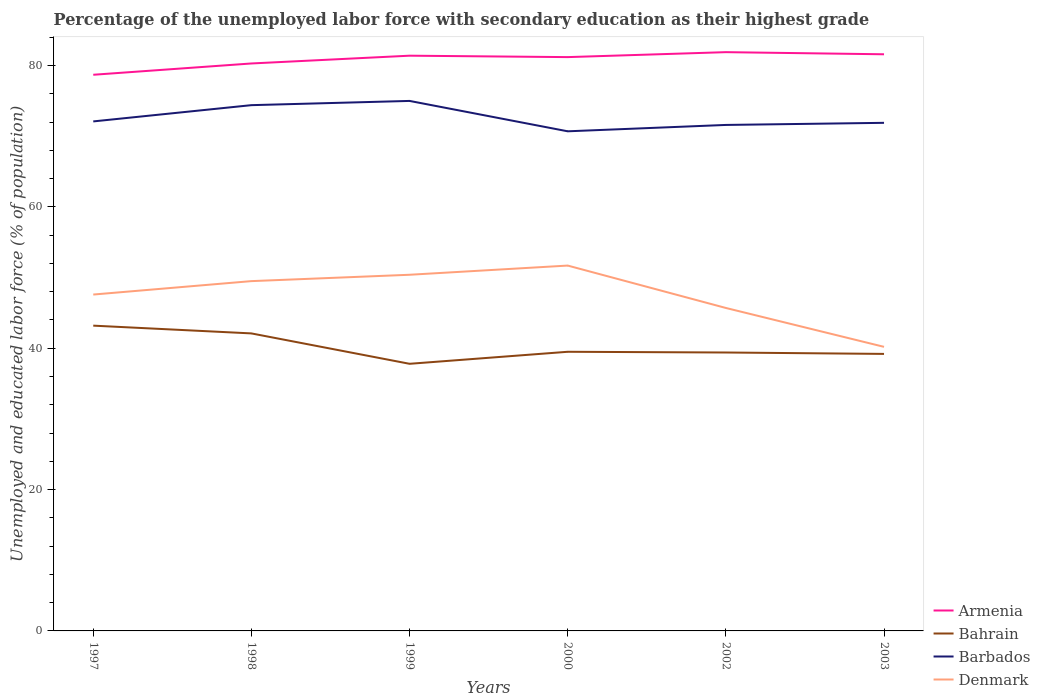How many different coloured lines are there?
Offer a very short reply. 4. Does the line corresponding to Denmark intersect with the line corresponding to Barbados?
Ensure brevity in your answer.  No. Is the number of lines equal to the number of legend labels?
Make the answer very short. Yes. Across all years, what is the maximum percentage of the unemployed labor force with secondary education in Bahrain?
Provide a short and direct response. 37.8. What is the total percentage of the unemployed labor force with secondary education in Armenia in the graph?
Your response must be concise. -0.5. What is the difference between the highest and the second highest percentage of the unemployed labor force with secondary education in Denmark?
Your answer should be compact. 11.5. How many years are there in the graph?
Provide a succinct answer. 6. What is the difference between two consecutive major ticks on the Y-axis?
Ensure brevity in your answer.  20. Where does the legend appear in the graph?
Your answer should be very brief. Bottom right. How many legend labels are there?
Keep it short and to the point. 4. What is the title of the graph?
Provide a short and direct response. Percentage of the unemployed labor force with secondary education as their highest grade. Does "Timor-Leste" appear as one of the legend labels in the graph?
Provide a short and direct response. No. What is the label or title of the X-axis?
Your response must be concise. Years. What is the label or title of the Y-axis?
Offer a terse response. Unemployed and educated labor force (% of population). What is the Unemployed and educated labor force (% of population) of Armenia in 1997?
Make the answer very short. 78.7. What is the Unemployed and educated labor force (% of population) of Bahrain in 1997?
Your answer should be very brief. 43.2. What is the Unemployed and educated labor force (% of population) in Barbados in 1997?
Keep it short and to the point. 72.1. What is the Unemployed and educated labor force (% of population) in Denmark in 1997?
Your response must be concise. 47.6. What is the Unemployed and educated labor force (% of population) in Armenia in 1998?
Keep it short and to the point. 80.3. What is the Unemployed and educated labor force (% of population) of Bahrain in 1998?
Give a very brief answer. 42.1. What is the Unemployed and educated labor force (% of population) of Barbados in 1998?
Your answer should be compact. 74.4. What is the Unemployed and educated labor force (% of population) in Denmark in 1998?
Make the answer very short. 49.5. What is the Unemployed and educated labor force (% of population) in Armenia in 1999?
Give a very brief answer. 81.4. What is the Unemployed and educated labor force (% of population) of Bahrain in 1999?
Ensure brevity in your answer.  37.8. What is the Unemployed and educated labor force (% of population) of Barbados in 1999?
Your answer should be very brief. 75. What is the Unemployed and educated labor force (% of population) in Denmark in 1999?
Your answer should be very brief. 50.4. What is the Unemployed and educated labor force (% of population) of Armenia in 2000?
Ensure brevity in your answer.  81.2. What is the Unemployed and educated labor force (% of population) in Bahrain in 2000?
Provide a succinct answer. 39.5. What is the Unemployed and educated labor force (% of population) in Barbados in 2000?
Offer a very short reply. 70.7. What is the Unemployed and educated labor force (% of population) in Denmark in 2000?
Give a very brief answer. 51.7. What is the Unemployed and educated labor force (% of population) in Armenia in 2002?
Your response must be concise. 81.9. What is the Unemployed and educated labor force (% of population) in Bahrain in 2002?
Your answer should be very brief. 39.4. What is the Unemployed and educated labor force (% of population) in Barbados in 2002?
Your answer should be very brief. 71.6. What is the Unemployed and educated labor force (% of population) of Denmark in 2002?
Offer a terse response. 45.7. What is the Unemployed and educated labor force (% of population) in Armenia in 2003?
Your answer should be very brief. 81.6. What is the Unemployed and educated labor force (% of population) in Bahrain in 2003?
Ensure brevity in your answer.  39.2. What is the Unemployed and educated labor force (% of population) in Barbados in 2003?
Offer a very short reply. 71.9. What is the Unemployed and educated labor force (% of population) of Denmark in 2003?
Your answer should be compact. 40.2. Across all years, what is the maximum Unemployed and educated labor force (% of population) of Armenia?
Give a very brief answer. 81.9. Across all years, what is the maximum Unemployed and educated labor force (% of population) of Bahrain?
Your response must be concise. 43.2. Across all years, what is the maximum Unemployed and educated labor force (% of population) in Denmark?
Your answer should be very brief. 51.7. Across all years, what is the minimum Unemployed and educated labor force (% of population) of Armenia?
Provide a succinct answer. 78.7. Across all years, what is the minimum Unemployed and educated labor force (% of population) in Bahrain?
Make the answer very short. 37.8. Across all years, what is the minimum Unemployed and educated labor force (% of population) in Barbados?
Your response must be concise. 70.7. Across all years, what is the minimum Unemployed and educated labor force (% of population) of Denmark?
Provide a short and direct response. 40.2. What is the total Unemployed and educated labor force (% of population) in Armenia in the graph?
Offer a terse response. 485.1. What is the total Unemployed and educated labor force (% of population) in Bahrain in the graph?
Give a very brief answer. 241.2. What is the total Unemployed and educated labor force (% of population) of Barbados in the graph?
Your answer should be very brief. 435.7. What is the total Unemployed and educated labor force (% of population) in Denmark in the graph?
Your answer should be very brief. 285.1. What is the difference between the Unemployed and educated labor force (% of population) of Armenia in 1997 and that in 1998?
Keep it short and to the point. -1.6. What is the difference between the Unemployed and educated labor force (% of population) of Bahrain in 1997 and that in 1998?
Your response must be concise. 1.1. What is the difference between the Unemployed and educated labor force (% of population) of Barbados in 1997 and that in 1998?
Your answer should be very brief. -2.3. What is the difference between the Unemployed and educated labor force (% of population) in Armenia in 1997 and that in 1999?
Your answer should be very brief. -2.7. What is the difference between the Unemployed and educated labor force (% of population) of Bahrain in 1997 and that in 1999?
Your answer should be very brief. 5.4. What is the difference between the Unemployed and educated labor force (% of population) of Barbados in 1997 and that in 1999?
Keep it short and to the point. -2.9. What is the difference between the Unemployed and educated labor force (% of population) of Denmark in 1997 and that in 1999?
Your response must be concise. -2.8. What is the difference between the Unemployed and educated labor force (% of population) of Armenia in 1997 and that in 2000?
Provide a succinct answer. -2.5. What is the difference between the Unemployed and educated labor force (% of population) of Barbados in 1997 and that in 2000?
Your answer should be compact. 1.4. What is the difference between the Unemployed and educated labor force (% of population) in Armenia in 1997 and that in 2002?
Ensure brevity in your answer.  -3.2. What is the difference between the Unemployed and educated labor force (% of population) of Bahrain in 1997 and that in 2002?
Your answer should be very brief. 3.8. What is the difference between the Unemployed and educated labor force (% of population) in Barbados in 1997 and that in 2002?
Your answer should be very brief. 0.5. What is the difference between the Unemployed and educated labor force (% of population) of Denmark in 1997 and that in 2002?
Keep it short and to the point. 1.9. What is the difference between the Unemployed and educated labor force (% of population) of Armenia in 1997 and that in 2003?
Provide a succinct answer. -2.9. What is the difference between the Unemployed and educated labor force (% of population) in Barbados in 1997 and that in 2003?
Offer a terse response. 0.2. What is the difference between the Unemployed and educated labor force (% of population) in Denmark in 1997 and that in 2003?
Offer a terse response. 7.4. What is the difference between the Unemployed and educated labor force (% of population) in Armenia in 1998 and that in 1999?
Offer a terse response. -1.1. What is the difference between the Unemployed and educated labor force (% of population) in Bahrain in 1998 and that in 1999?
Your answer should be compact. 4.3. What is the difference between the Unemployed and educated labor force (% of population) of Barbados in 1998 and that in 2000?
Keep it short and to the point. 3.7. What is the difference between the Unemployed and educated labor force (% of population) in Denmark in 1998 and that in 2000?
Offer a very short reply. -2.2. What is the difference between the Unemployed and educated labor force (% of population) of Denmark in 1998 and that in 2002?
Offer a very short reply. 3.8. What is the difference between the Unemployed and educated labor force (% of population) in Armenia in 1998 and that in 2003?
Your answer should be compact. -1.3. What is the difference between the Unemployed and educated labor force (% of population) in Barbados in 1998 and that in 2003?
Make the answer very short. 2.5. What is the difference between the Unemployed and educated labor force (% of population) of Bahrain in 1999 and that in 2000?
Your answer should be very brief. -1.7. What is the difference between the Unemployed and educated labor force (% of population) of Barbados in 1999 and that in 2000?
Give a very brief answer. 4.3. What is the difference between the Unemployed and educated labor force (% of population) in Armenia in 1999 and that in 2002?
Provide a short and direct response. -0.5. What is the difference between the Unemployed and educated labor force (% of population) of Barbados in 1999 and that in 2002?
Your response must be concise. 3.4. What is the difference between the Unemployed and educated labor force (% of population) of Armenia in 1999 and that in 2003?
Offer a very short reply. -0.2. What is the difference between the Unemployed and educated labor force (% of population) of Bahrain in 1999 and that in 2003?
Ensure brevity in your answer.  -1.4. What is the difference between the Unemployed and educated labor force (% of population) of Barbados in 1999 and that in 2003?
Give a very brief answer. 3.1. What is the difference between the Unemployed and educated labor force (% of population) of Bahrain in 2000 and that in 2002?
Your answer should be very brief. 0.1. What is the difference between the Unemployed and educated labor force (% of population) of Denmark in 2000 and that in 2003?
Your response must be concise. 11.5. What is the difference between the Unemployed and educated labor force (% of population) of Armenia in 2002 and that in 2003?
Keep it short and to the point. 0.3. What is the difference between the Unemployed and educated labor force (% of population) of Armenia in 1997 and the Unemployed and educated labor force (% of population) of Bahrain in 1998?
Your answer should be very brief. 36.6. What is the difference between the Unemployed and educated labor force (% of population) of Armenia in 1997 and the Unemployed and educated labor force (% of population) of Denmark in 1998?
Your response must be concise. 29.2. What is the difference between the Unemployed and educated labor force (% of population) in Bahrain in 1997 and the Unemployed and educated labor force (% of population) in Barbados in 1998?
Give a very brief answer. -31.2. What is the difference between the Unemployed and educated labor force (% of population) in Barbados in 1997 and the Unemployed and educated labor force (% of population) in Denmark in 1998?
Offer a very short reply. 22.6. What is the difference between the Unemployed and educated labor force (% of population) of Armenia in 1997 and the Unemployed and educated labor force (% of population) of Bahrain in 1999?
Offer a terse response. 40.9. What is the difference between the Unemployed and educated labor force (% of population) in Armenia in 1997 and the Unemployed and educated labor force (% of population) in Barbados in 1999?
Your answer should be very brief. 3.7. What is the difference between the Unemployed and educated labor force (% of population) of Armenia in 1997 and the Unemployed and educated labor force (% of population) of Denmark in 1999?
Give a very brief answer. 28.3. What is the difference between the Unemployed and educated labor force (% of population) in Bahrain in 1997 and the Unemployed and educated labor force (% of population) in Barbados in 1999?
Give a very brief answer. -31.8. What is the difference between the Unemployed and educated labor force (% of population) in Bahrain in 1997 and the Unemployed and educated labor force (% of population) in Denmark in 1999?
Your response must be concise. -7.2. What is the difference between the Unemployed and educated labor force (% of population) in Barbados in 1997 and the Unemployed and educated labor force (% of population) in Denmark in 1999?
Your answer should be very brief. 21.7. What is the difference between the Unemployed and educated labor force (% of population) in Armenia in 1997 and the Unemployed and educated labor force (% of population) in Bahrain in 2000?
Provide a short and direct response. 39.2. What is the difference between the Unemployed and educated labor force (% of population) in Bahrain in 1997 and the Unemployed and educated labor force (% of population) in Barbados in 2000?
Your answer should be compact. -27.5. What is the difference between the Unemployed and educated labor force (% of population) in Bahrain in 1997 and the Unemployed and educated labor force (% of population) in Denmark in 2000?
Offer a very short reply. -8.5. What is the difference between the Unemployed and educated labor force (% of population) of Barbados in 1997 and the Unemployed and educated labor force (% of population) of Denmark in 2000?
Make the answer very short. 20.4. What is the difference between the Unemployed and educated labor force (% of population) of Armenia in 1997 and the Unemployed and educated labor force (% of population) of Bahrain in 2002?
Offer a terse response. 39.3. What is the difference between the Unemployed and educated labor force (% of population) in Armenia in 1997 and the Unemployed and educated labor force (% of population) in Denmark in 2002?
Make the answer very short. 33. What is the difference between the Unemployed and educated labor force (% of population) in Bahrain in 1997 and the Unemployed and educated labor force (% of population) in Barbados in 2002?
Ensure brevity in your answer.  -28.4. What is the difference between the Unemployed and educated labor force (% of population) in Barbados in 1997 and the Unemployed and educated labor force (% of population) in Denmark in 2002?
Provide a succinct answer. 26.4. What is the difference between the Unemployed and educated labor force (% of population) of Armenia in 1997 and the Unemployed and educated labor force (% of population) of Bahrain in 2003?
Your answer should be compact. 39.5. What is the difference between the Unemployed and educated labor force (% of population) of Armenia in 1997 and the Unemployed and educated labor force (% of population) of Barbados in 2003?
Make the answer very short. 6.8. What is the difference between the Unemployed and educated labor force (% of population) of Armenia in 1997 and the Unemployed and educated labor force (% of population) of Denmark in 2003?
Ensure brevity in your answer.  38.5. What is the difference between the Unemployed and educated labor force (% of population) of Bahrain in 1997 and the Unemployed and educated labor force (% of population) of Barbados in 2003?
Provide a succinct answer. -28.7. What is the difference between the Unemployed and educated labor force (% of population) of Barbados in 1997 and the Unemployed and educated labor force (% of population) of Denmark in 2003?
Ensure brevity in your answer.  31.9. What is the difference between the Unemployed and educated labor force (% of population) in Armenia in 1998 and the Unemployed and educated labor force (% of population) in Bahrain in 1999?
Make the answer very short. 42.5. What is the difference between the Unemployed and educated labor force (% of population) in Armenia in 1998 and the Unemployed and educated labor force (% of population) in Barbados in 1999?
Give a very brief answer. 5.3. What is the difference between the Unemployed and educated labor force (% of population) of Armenia in 1998 and the Unemployed and educated labor force (% of population) of Denmark in 1999?
Offer a terse response. 29.9. What is the difference between the Unemployed and educated labor force (% of population) in Bahrain in 1998 and the Unemployed and educated labor force (% of population) in Barbados in 1999?
Keep it short and to the point. -32.9. What is the difference between the Unemployed and educated labor force (% of population) of Bahrain in 1998 and the Unemployed and educated labor force (% of population) of Denmark in 1999?
Offer a very short reply. -8.3. What is the difference between the Unemployed and educated labor force (% of population) in Armenia in 1998 and the Unemployed and educated labor force (% of population) in Bahrain in 2000?
Your answer should be compact. 40.8. What is the difference between the Unemployed and educated labor force (% of population) of Armenia in 1998 and the Unemployed and educated labor force (% of population) of Barbados in 2000?
Provide a succinct answer. 9.6. What is the difference between the Unemployed and educated labor force (% of population) in Armenia in 1998 and the Unemployed and educated labor force (% of population) in Denmark in 2000?
Your answer should be compact. 28.6. What is the difference between the Unemployed and educated labor force (% of population) of Bahrain in 1998 and the Unemployed and educated labor force (% of population) of Barbados in 2000?
Provide a succinct answer. -28.6. What is the difference between the Unemployed and educated labor force (% of population) of Barbados in 1998 and the Unemployed and educated labor force (% of population) of Denmark in 2000?
Give a very brief answer. 22.7. What is the difference between the Unemployed and educated labor force (% of population) of Armenia in 1998 and the Unemployed and educated labor force (% of population) of Bahrain in 2002?
Provide a short and direct response. 40.9. What is the difference between the Unemployed and educated labor force (% of population) of Armenia in 1998 and the Unemployed and educated labor force (% of population) of Denmark in 2002?
Keep it short and to the point. 34.6. What is the difference between the Unemployed and educated labor force (% of population) of Bahrain in 1998 and the Unemployed and educated labor force (% of population) of Barbados in 2002?
Give a very brief answer. -29.5. What is the difference between the Unemployed and educated labor force (% of population) of Barbados in 1998 and the Unemployed and educated labor force (% of population) of Denmark in 2002?
Make the answer very short. 28.7. What is the difference between the Unemployed and educated labor force (% of population) in Armenia in 1998 and the Unemployed and educated labor force (% of population) in Bahrain in 2003?
Offer a very short reply. 41.1. What is the difference between the Unemployed and educated labor force (% of population) of Armenia in 1998 and the Unemployed and educated labor force (% of population) of Barbados in 2003?
Provide a short and direct response. 8.4. What is the difference between the Unemployed and educated labor force (% of population) in Armenia in 1998 and the Unemployed and educated labor force (% of population) in Denmark in 2003?
Make the answer very short. 40.1. What is the difference between the Unemployed and educated labor force (% of population) in Bahrain in 1998 and the Unemployed and educated labor force (% of population) in Barbados in 2003?
Give a very brief answer. -29.8. What is the difference between the Unemployed and educated labor force (% of population) in Bahrain in 1998 and the Unemployed and educated labor force (% of population) in Denmark in 2003?
Your answer should be compact. 1.9. What is the difference between the Unemployed and educated labor force (% of population) in Barbados in 1998 and the Unemployed and educated labor force (% of population) in Denmark in 2003?
Your response must be concise. 34.2. What is the difference between the Unemployed and educated labor force (% of population) in Armenia in 1999 and the Unemployed and educated labor force (% of population) in Bahrain in 2000?
Your answer should be compact. 41.9. What is the difference between the Unemployed and educated labor force (% of population) in Armenia in 1999 and the Unemployed and educated labor force (% of population) in Denmark in 2000?
Your answer should be very brief. 29.7. What is the difference between the Unemployed and educated labor force (% of population) in Bahrain in 1999 and the Unemployed and educated labor force (% of population) in Barbados in 2000?
Your answer should be very brief. -32.9. What is the difference between the Unemployed and educated labor force (% of population) in Barbados in 1999 and the Unemployed and educated labor force (% of population) in Denmark in 2000?
Provide a succinct answer. 23.3. What is the difference between the Unemployed and educated labor force (% of population) of Armenia in 1999 and the Unemployed and educated labor force (% of population) of Denmark in 2002?
Make the answer very short. 35.7. What is the difference between the Unemployed and educated labor force (% of population) in Bahrain in 1999 and the Unemployed and educated labor force (% of population) in Barbados in 2002?
Offer a terse response. -33.8. What is the difference between the Unemployed and educated labor force (% of population) in Barbados in 1999 and the Unemployed and educated labor force (% of population) in Denmark in 2002?
Your answer should be compact. 29.3. What is the difference between the Unemployed and educated labor force (% of population) of Armenia in 1999 and the Unemployed and educated labor force (% of population) of Bahrain in 2003?
Your answer should be compact. 42.2. What is the difference between the Unemployed and educated labor force (% of population) of Armenia in 1999 and the Unemployed and educated labor force (% of population) of Barbados in 2003?
Your response must be concise. 9.5. What is the difference between the Unemployed and educated labor force (% of population) in Armenia in 1999 and the Unemployed and educated labor force (% of population) in Denmark in 2003?
Keep it short and to the point. 41.2. What is the difference between the Unemployed and educated labor force (% of population) of Bahrain in 1999 and the Unemployed and educated labor force (% of population) of Barbados in 2003?
Provide a short and direct response. -34.1. What is the difference between the Unemployed and educated labor force (% of population) of Barbados in 1999 and the Unemployed and educated labor force (% of population) of Denmark in 2003?
Your answer should be compact. 34.8. What is the difference between the Unemployed and educated labor force (% of population) in Armenia in 2000 and the Unemployed and educated labor force (% of population) in Bahrain in 2002?
Ensure brevity in your answer.  41.8. What is the difference between the Unemployed and educated labor force (% of population) in Armenia in 2000 and the Unemployed and educated labor force (% of population) in Barbados in 2002?
Give a very brief answer. 9.6. What is the difference between the Unemployed and educated labor force (% of population) of Armenia in 2000 and the Unemployed and educated labor force (% of population) of Denmark in 2002?
Make the answer very short. 35.5. What is the difference between the Unemployed and educated labor force (% of population) of Bahrain in 2000 and the Unemployed and educated labor force (% of population) of Barbados in 2002?
Provide a succinct answer. -32.1. What is the difference between the Unemployed and educated labor force (% of population) of Bahrain in 2000 and the Unemployed and educated labor force (% of population) of Denmark in 2002?
Your answer should be very brief. -6.2. What is the difference between the Unemployed and educated labor force (% of population) in Barbados in 2000 and the Unemployed and educated labor force (% of population) in Denmark in 2002?
Ensure brevity in your answer.  25. What is the difference between the Unemployed and educated labor force (% of population) in Armenia in 2000 and the Unemployed and educated labor force (% of population) in Bahrain in 2003?
Keep it short and to the point. 42. What is the difference between the Unemployed and educated labor force (% of population) of Armenia in 2000 and the Unemployed and educated labor force (% of population) of Denmark in 2003?
Provide a succinct answer. 41. What is the difference between the Unemployed and educated labor force (% of population) of Bahrain in 2000 and the Unemployed and educated labor force (% of population) of Barbados in 2003?
Your response must be concise. -32.4. What is the difference between the Unemployed and educated labor force (% of population) of Barbados in 2000 and the Unemployed and educated labor force (% of population) of Denmark in 2003?
Provide a succinct answer. 30.5. What is the difference between the Unemployed and educated labor force (% of population) of Armenia in 2002 and the Unemployed and educated labor force (% of population) of Bahrain in 2003?
Make the answer very short. 42.7. What is the difference between the Unemployed and educated labor force (% of population) in Armenia in 2002 and the Unemployed and educated labor force (% of population) in Denmark in 2003?
Offer a terse response. 41.7. What is the difference between the Unemployed and educated labor force (% of population) in Bahrain in 2002 and the Unemployed and educated labor force (% of population) in Barbados in 2003?
Give a very brief answer. -32.5. What is the difference between the Unemployed and educated labor force (% of population) in Bahrain in 2002 and the Unemployed and educated labor force (% of population) in Denmark in 2003?
Offer a very short reply. -0.8. What is the difference between the Unemployed and educated labor force (% of population) of Barbados in 2002 and the Unemployed and educated labor force (% of population) of Denmark in 2003?
Offer a very short reply. 31.4. What is the average Unemployed and educated labor force (% of population) of Armenia per year?
Make the answer very short. 80.85. What is the average Unemployed and educated labor force (% of population) of Bahrain per year?
Offer a very short reply. 40.2. What is the average Unemployed and educated labor force (% of population) in Barbados per year?
Keep it short and to the point. 72.62. What is the average Unemployed and educated labor force (% of population) in Denmark per year?
Give a very brief answer. 47.52. In the year 1997, what is the difference between the Unemployed and educated labor force (% of population) of Armenia and Unemployed and educated labor force (% of population) of Bahrain?
Keep it short and to the point. 35.5. In the year 1997, what is the difference between the Unemployed and educated labor force (% of population) in Armenia and Unemployed and educated labor force (% of population) in Denmark?
Offer a terse response. 31.1. In the year 1997, what is the difference between the Unemployed and educated labor force (% of population) in Bahrain and Unemployed and educated labor force (% of population) in Barbados?
Offer a very short reply. -28.9. In the year 1997, what is the difference between the Unemployed and educated labor force (% of population) in Bahrain and Unemployed and educated labor force (% of population) in Denmark?
Ensure brevity in your answer.  -4.4. In the year 1998, what is the difference between the Unemployed and educated labor force (% of population) of Armenia and Unemployed and educated labor force (% of population) of Bahrain?
Offer a very short reply. 38.2. In the year 1998, what is the difference between the Unemployed and educated labor force (% of population) in Armenia and Unemployed and educated labor force (% of population) in Barbados?
Ensure brevity in your answer.  5.9. In the year 1998, what is the difference between the Unemployed and educated labor force (% of population) of Armenia and Unemployed and educated labor force (% of population) of Denmark?
Provide a short and direct response. 30.8. In the year 1998, what is the difference between the Unemployed and educated labor force (% of population) of Bahrain and Unemployed and educated labor force (% of population) of Barbados?
Your answer should be compact. -32.3. In the year 1998, what is the difference between the Unemployed and educated labor force (% of population) of Barbados and Unemployed and educated labor force (% of population) of Denmark?
Give a very brief answer. 24.9. In the year 1999, what is the difference between the Unemployed and educated labor force (% of population) of Armenia and Unemployed and educated labor force (% of population) of Bahrain?
Ensure brevity in your answer.  43.6. In the year 1999, what is the difference between the Unemployed and educated labor force (% of population) of Armenia and Unemployed and educated labor force (% of population) of Barbados?
Provide a succinct answer. 6.4. In the year 1999, what is the difference between the Unemployed and educated labor force (% of population) of Armenia and Unemployed and educated labor force (% of population) of Denmark?
Keep it short and to the point. 31. In the year 1999, what is the difference between the Unemployed and educated labor force (% of population) in Bahrain and Unemployed and educated labor force (% of population) in Barbados?
Offer a very short reply. -37.2. In the year 1999, what is the difference between the Unemployed and educated labor force (% of population) in Bahrain and Unemployed and educated labor force (% of population) in Denmark?
Your response must be concise. -12.6. In the year 1999, what is the difference between the Unemployed and educated labor force (% of population) of Barbados and Unemployed and educated labor force (% of population) of Denmark?
Offer a very short reply. 24.6. In the year 2000, what is the difference between the Unemployed and educated labor force (% of population) in Armenia and Unemployed and educated labor force (% of population) in Bahrain?
Give a very brief answer. 41.7. In the year 2000, what is the difference between the Unemployed and educated labor force (% of population) of Armenia and Unemployed and educated labor force (% of population) of Barbados?
Give a very brief answer. 10.5. In the year 2000, what is the difference between the Unemployed and educated labor force (% of population) of Armenia and Unemployed and educated labor force (% of population) of Denmark?
Ensure brevity in your answer.  29.5. In the year 2000, what is the difference between the Unemployed and educated labor force (% of population) in Bahrain and Unemployed and educated labor force (% of population) in Barbados?
Offer a terse response. -31.2. In the year 2000, what is the difference between the Unemployed and educated labor force (% of population) in Bahrain and Unemployed and educated labor force (% of population) in Denmark?
Your answer should be compact. -12.2. In the year 2002, what is the difference between the Unemployed and educated labor force (% of population) in Armenia and Unemployed and educated labor force (% of population) in Bahrain?
Provide a short and direct response. 42.5. In the year 2002, what is the difference between the Unemployed and educated labor force (% of population) in Armenia and Unemployed and educated labor force (% of population) in Barbados?
Offer a terse response. 10.3. In the year 2002, what is the difference between the Unemployed and educated labor force (% of population) of Armenia and Unemployed and educated labor force (% of population) of Denmark?
Your answer should be compact. 36.2. In the year 2002, what is the difference between the Unemployed and educated labor force (% of population) in Bahrain and Unemployed and educated labor force (% of population) in Barbados?
Offer a very short reply. -32.2. In the year 2002, what is the difference between the Unemployed and educated labor force (% of population) in Bahrain and Unemployed and educated labor force (% of population) in Denmark?
Your answer should be compact. -6.3. In the year 2002, what is the difference between the Unemployed and educated labor force (% of population) of Barbados and Unemployed and educated labor force (% of population) of Denmark?
Ensure brevity in your answer.  25.9. In the year 2003, what is the difference between the Unemployed and educated labor force (% of population) of Armenia and Unemployed and educated labor force (% of population) of Bahrain?
Your response must be concise. 42.4. In the year 2003, what is the difference between the Unemployed and educated labor force (% of population) of Armenia and Unemployed and educated labor force (% of population) of Denmark?
Offer a very short reply. 41.4. In the year 2003, what is the difference between the Unemployed and educated labor force (% of population) of Bahrain and Unemployed and educated labor force (% of population) of Barbados?
Offer a terse response. -32.7. In the year 2003, what is the difference between the Unemployed and educated labor force (% of population) of Barbados and Unemployed and educated labor force (% of population) of Denmark?
Make the answer very short. 31.7. What is the ratio of the Unemployed and educated labor force (% of population) of Armenia in 1997 to that in 1998?
Provide a short and direct response. 0.98. What is the ratio of the Unemployed and educated labor force (% of population) in Bahrain in 1997 to that in 1998?
Your answer should be compact. 1.03. What is the ratio of the Unemployed and educated labor force (% of population) in Barbados in 1997 to that in 1998?
Provide a succinct answer. 0.97. What is the ratio of the Unemployed and educated labor force (% of population) in Denmark in 1997 to that in 1998?
Make the answer very short. 0.96. What is the ratio of the Unemployed and educated labor force (% of population) in Armenia in 1997 to that in 1999?
Your answer should be compact. 0.97. What is the ratio of the Unemployed and educated labor force (% of population) in Bahrain in 1997 to that in 1999?
Your response must be concise. 1.14. What is the ratio of the Unemployed and educated labor force (% of population) of Barbados in 1997 to that in 1999?
Provide a short and direct response. 0.96. What is the ratio of the Unemployed and educated labor force (% of population) of Armenia in 1997 to that in 2000?
Offer a terse response. 0.97. What is the ratio of the Unemployed and educated labor force (% of population) in Bahrain in 1997 to that in 2000?
Keep it short and to the point. 1.09. What is the ratio of the Unemployed and educated labor force (% of population) of Barbados in 1997 to that in 2000?
Your answer should be very brief. 1.02. What is the ratio of the Unemployed and educated labor force (% of population) of Denmark in 1997 to that in 2000?
Ensure brevity in your answer.  0.92. What is the ratio of the Unemployed and educated labor force (% of population) in Armenia in 1997 to that in 2002?
Your response must be concise. 0.96. What is the ratio of the Unemployed and educated labor force (% of population) in Bahrain in 1997 to that in 2002?
Your response must be concise. 1.1. What is the ratio of the Unemployed and educated labor force (% of population) of Denmark in 1997 to that in 2002?
Provide a short and direct response. 1.04. What is the ratio of the Unemployed and educated labor force (% of population) in Armenia in 1997 to that in 2003?
Your answer should be very brief. 0.96. What is the ratio of the Unemployed and educated labor force (% of population) of Bahrain in 1997 to that in 2003?
Your answer should be very brief. 1.1. What is the ratio of the Unemployed and educated labor force (% of population) in Barbados in 1997 to that in 2003?
Offer a very short reply. 1. What is the ratio of the Unemployed and educated labor force (% of population) in Denmark in 1997 to that in 2003?
Your answer should be compact. 1.18. What is the ratio of the Unemployed and educated labor force (% of population) in Armenia in 1998 to that in 1999?
Your answer should be very brief. 0.99. What is the ratio of the Unemployed and educated labor force (% of population) of Bahrain in 1998 to that in 1999?
Your answer should be compact. 1.11. What is the ratio of the Unemployed and educated labor force (% of population) in Denmark in 1998 to that in 1999?
Your answer should be very brief. 0.98. What is the ratio of the Unemployed and educated labor force (% of population) of Armenia in 1998 to that in 2000?
Provide a succinct answer. 0.99. What is the ratio of the Unemployed and educated labor force (% of population) in Bahrain in 1998 to that in 2000?
Your response must be concise. 1.07. What is the ratio of the Unemployed and educated labor force (% of population) in Barbados in 1998 to that in 2000?
Give a very brief answer. 1.05. What is the ratio of the Unemployed and educated labor force (% of population) of Denmark in 1998 to that in 2000?
Your response must be concise. 0.96. What is the ratio of the Unemployed and educated labor force (% of population) of Armenia in 1998 to that in 2002?
Provide a succinct answer. 0.98. What is the ratio of the Unemployed and educated labor force (% of population) in Bahrain in 1998 to that in 2002?
Your answer should be compact. 1.07. What is the ratio of the Unemployed and educated labor force (% of population) of Barbados in 1998 to that in 2002?
Offer a very short reply. 1.04. What is the ratio of the Unemployed and educated labor force (% of population) in Denmark in 1998 to that in 2002?
Your answer should be very brief. 1.08. What is the ratio of the Unemployed and educated labor force (% of population) of Armenia in 1998 to that in 2003?
Ensure brevity in your answer.  0.98. What is the ratio of the Unemployed and educated labor force (% of population) in Bahrain in 1998 to that in 2003?
Keep it short and to the point. 1.07. What is the ratio of the Unemployed and educated labor force (% of population) of Barbados in 1998 to that in 2003?
Your answer should be compact. 1.03. What is the ratio of the Unemployed and educated labor force (% of population) in Denmark in 1998 to that in 2003?
Offer a terse response. 1.23. What is the ratio of the Unemployed and educated labor force (% of population) in Bahrain in 1999 to that in 2000?
Make the answer very short. 0.96. What is the ratio of the Unemployed and educated labor force (% of population) of Barbados in 1999 to that in 2000?
Your answer should be compact. 1.06. What is the ratio of the Unemployed and educated labor force (% of population) of Denmark in 1999 to that in 2000?
Ensure brevity in your answer.  0.97. What is the ratio of the Unemployed and educated labor force (% of population) of Armenia in 1999 to that in 2002?
Make the answer very short. 0.99. What is the ratio of the Unemployed and educated labor force (% of population) of Bahrain in 1999 to that in 2002?
Provide a short and direct response. 0.96. What is the ratio of the Unemployed and educated labor force (% of population) of Barbados in 1999 to that in 2002?
Offer a very short reply. 1.05. What is the ratio of the Unemployed and educated labor force (% of population) of Denmark in 1999 to that in 2002?
Make the answer very short. 1.1. What is the ratio of the Unemployed and educated labor force (% of population) of Bahrain in 1999 to that in 2003?
Offer a very short reply. 0.96. What is the ratio of the Unemployed and educated labor force (% of population) in Barbados in 1999 to that in 2003?
Provide a succinct answer. 1.04. What is the ratio of the Unemployed and educated labor force (% of population) in Denmark in 1999 to that in 2003?
Offer a very short reply. 1.25. What is the ratio of the Unemployed and educated labor force (% of population) of Armenia in 2000 to that in 2002?
Your answer should be compact. 0.99. What is the ratio of the Unemployed and educated labor force (% of population) of Bahrain in 2000 to that in 2002?
Give a very brief answer. 1. What is the ratio of the Unemployed and educated labor force (% of population) of Barbados in 2000 to that in 2002?
Offer a terse response. 0.99. What is the ratio of the Unemployed and educated labor force (% of population) in Denmark in 2000 to that in 2002?
Your answer should be very brief. 1.13. What is the ratio of the Unemployed and educated labor force (% of population) of Bahrain in 2000 to that in 2003?
Your answer should be very brief. 1.01. What is the ratio of the Unemployed and educated labor force (% of population) of Barbados in 2000 to that in 2003?
Make the answer very short. 0.98. What is the ratio of the Unemployed and educated labor force (% of population) in Denmark in 2000 to that in 2003?
Give a very brief answer. 1.29. What is the ratio of the Unemployed and educated labor force (% of population) in Barbados in 2002 to that in 2003?
Provide a succinct answer. 1. What is the ratio of the Unemployed and educated labor force (% of population) in Denmark in 2002 to that in 2003?
Make the answer very short. 1.14. What is the difference between the highest and the second highest Unemployed and educated labor force (% of population) in Bahrain?
Provide a succinct answer. 1.1. What is the difference between the highest and the second highest Unemployed and educated labor force (% of population) of Barbados?
Give a very brief answer. 0.6. What is the difference between the highest and the second highest Unemployed and educated labor force (% of population) of Denmark?
Your response must be concise. 1.3. What is the difference between the highest and the lowest Unemployed and educated labor force (% of population) in Bahrain?
Provide a succinct answer. 5.4. What is the difference between the highest and the lowest Unemployed and educated labor force (% of population) in Denmark?
Make the answer very short. 11.5. 